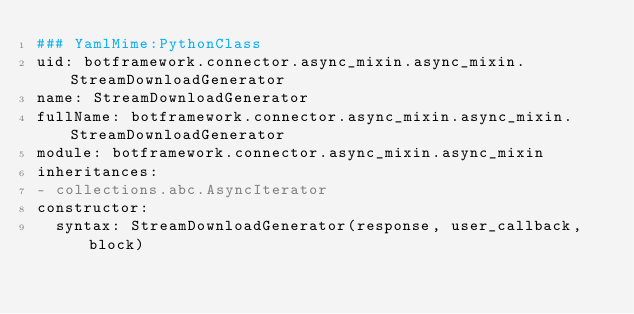Convert code to text. <code><loc_0><loc_0><loc_500><loc_500><_YAML_>### YamlMime:PythonClass
uid: botframework.connector.async_mixin.async_mixin.StreamDownloadGenerator
name: StreamDownloadGenerator
fullName: botframework.connector.async_mixin.async_mixin.StreamDownloadGenerator
module: botframework.connector.async_mixin.async_mixin
inheritances:
- collections.abc.AsyncIterator
constructor:
  syntax: StreamDownloadGenerator(response, user_callback, block)
</code> 